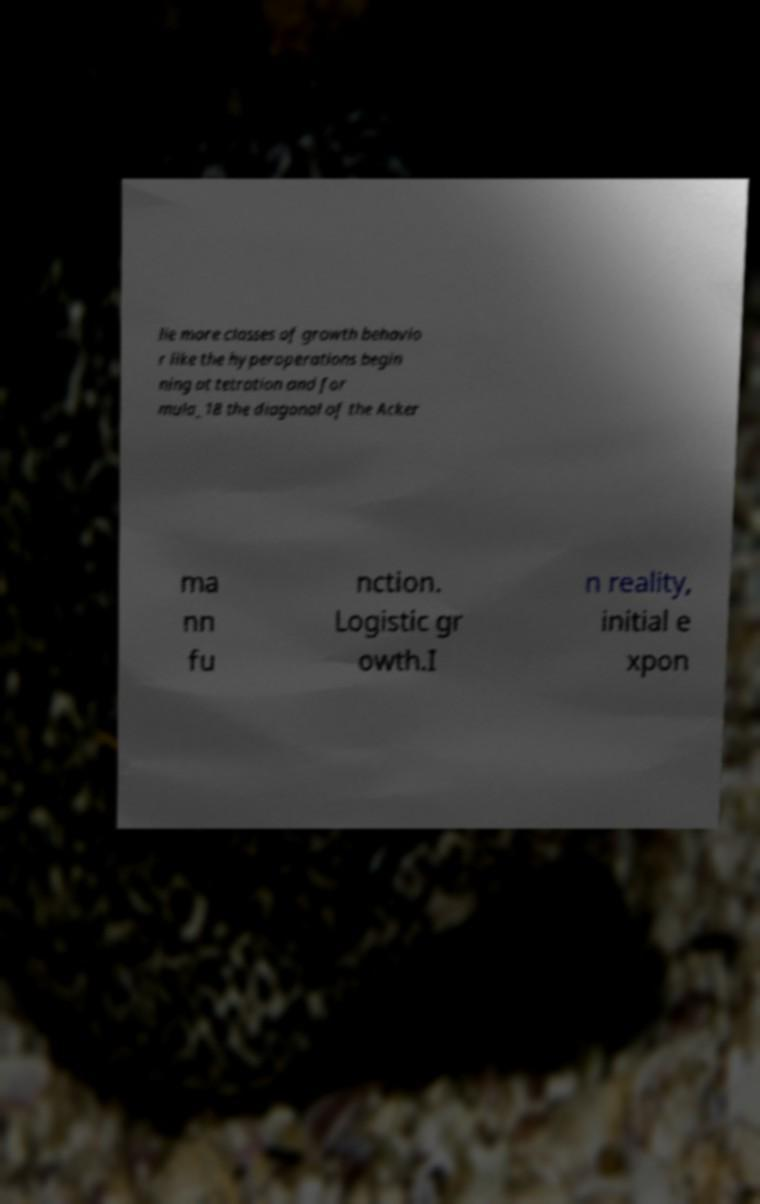Can you read and provide the text displayed in the image?This photo seems to have some interesting text. Can you extract and type it out for me? lie more classes of growth behavio r like the hyperoperations begin ning at tetration and for mula_18 the diagonal of the Acker ma nn fu nction. Logistic gr owth.I n reality, initial e xpon 